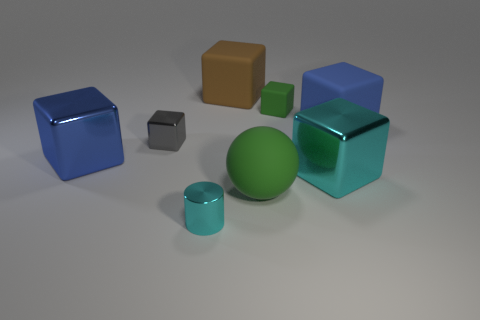Is there any other thing that has the same color as the small metal block?
Your answer should be compact. No. Are any large green things visible?
Your answer should be very brief. Yes. Are there any big objects in front of the big cyan metal cube?
Provide a succinct answer. Yes. There is another big blue thing that is the same shape as the blue rubber object; what is it made of?
Provide a succinct answer. Metal. What number of other things are there of the same shape as the blue matte object?
Provide a short and direct response. 5. What number of large rubber objects are on the right side of the large blue cube to the left of the big blue object on the right side of the small gray cube?
Your response must be concise. 3. How many big yellow matte things are the same shape as the big cyan object?
Ensure brevity in your answer.  0. Do the cube that is left of the small gray metal thing and the large sphere have the same color?
Provide a succinct answer. No. What is the shape of the large blue object that is on the left side of the big metallic object that is in front of the blue block to the left of the gray metal block?
Offer a terse response. Cube. Do the gray cube and the green object behind the big blue rubber thing have the same size?
Give a very brief answer. Yes. 